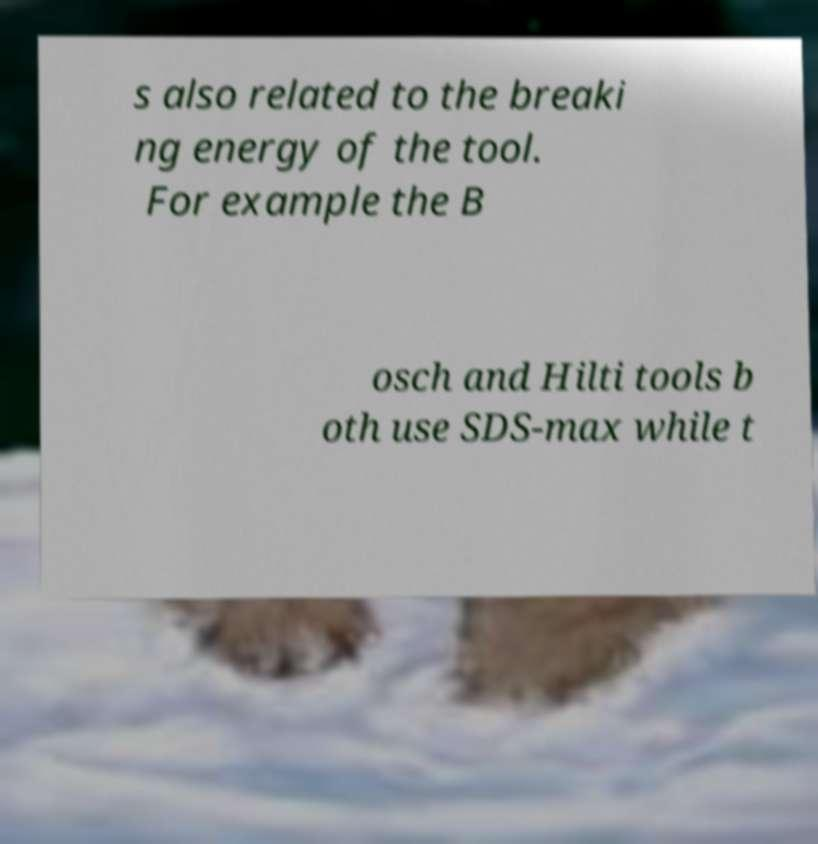Can you accurately transcribe the text from the provided image for me? s also related to the breaki ng energy of the tool. For example the B osch and Hilti tools b oth use SDS-max while t 